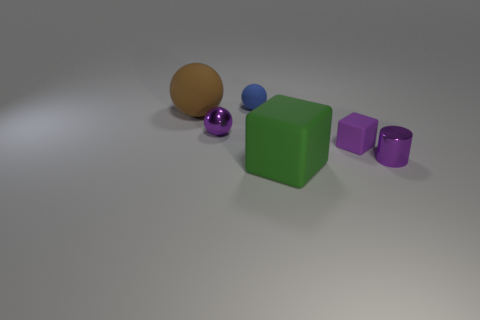Add 2 big brown balls. How many objects exist? 8 Subtract all blocks. How many objects are left? 4 Subtract all tiny spheres. Subtract all purple things. How many objects are left? 1 Add 1 blocks. How many blocks are left? 3 Add 1 blue objects. How many blue objects exist? 2 Subtract 0 cyan balls. How many objects are left? 6 